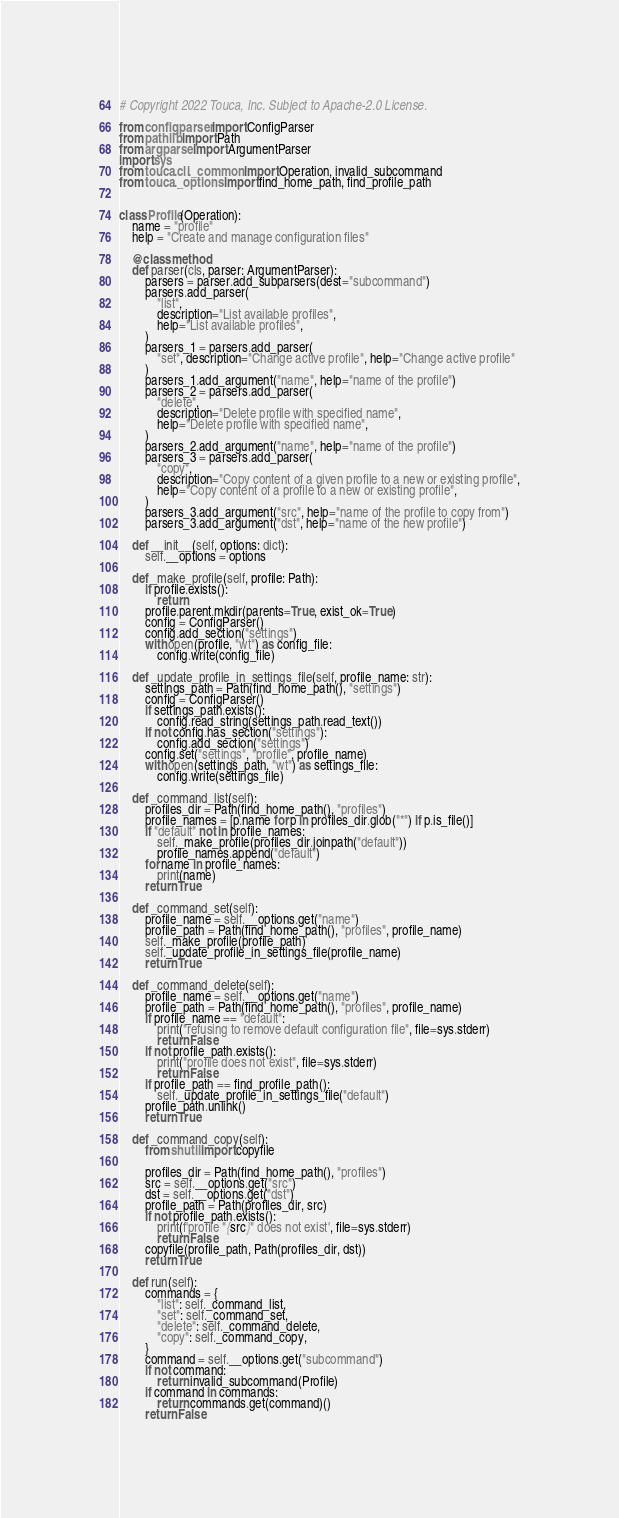Convert code to text. <code><loc_0><loc_0><loc_500><loc_500><_Python_># Copyright 2022 Touca, Inc. Subject to Apache-2.0 License.

from configparser import ConfigParser
from pathlib import Path
from argparse import ArgumentParser
import sys
from touca.cli._common import Operation, invalid_subcommand
from touca._options import find_home_path, find_profile_path


class Profile(Operation):
    name = "profile"
    help = "Create and manage configuration files"

    @classmethod
    def parser(cls, parser: ArgumentParser):
        parsers = parser.add_subparsers(dest="subcommand")
        parsers.add_parser(
            "list",
            description="List available profiles",
            help="List available profiles",
        )
        parsers_1 = parsers.add_parser(
            "set", description="Change active profile", help="Change active profile"
        )
        parsers_1.add_argument("name", help="name of the profile")
        parsers_2 = parsers.add_parser(
            "delete",
            description="Delete profile with specified name",
            help="Delete profile with specified name",
        )
        parsers_2.add_argument("name", help="name of the profile")
        parsers_3 = parsers.add_parser(
            "copy",
            description="Copy content of a given profile to a new or existing profile",
            help="Copy content of a profile to a new or existing profile",
        )
        parsers_3.add_argument("src", help="name of the profile to copy from")
        parsers_3.add_argument("dst", help="name of the new profile")

    def __init__(self, options: dict):
        self.__options = options

    def _make_profile(self, profile: Path):
        if profile.exists():
            return
        profile.parent.mkdir(parents=True, exist_ok=True)
        config = ConfigParser()
        config.add_section("settings")
        with open(profile, "wt") as config_file:
            config.write(config_file)

    def _update_profile_in_settings_file(self, profile_name: str):
        settings_path = Path(find_home_path(), "settings")
        config = ConfigParser()
        if settings_path.exists():
            config.read_string(settings_path.read_text())
        if not config.has_section("settings"):
            config.add_section("settings")
        config.set("settings", "profile", profile_name)
        with open(settings_path, "wt") as settings_file:
            config.write(settings_file)

    def _command_list(self):
        profiles_dir = Path(find_home_path(), "profiles")
        profile_names = [p.name for p in profiles_dir.glob("*") if p.is_file()]
        if "default" not in profile_names:
            self._make_profile(profiles_dir.joinpath("default"))
            profile_names.append("default")
        for name in profile_names:
            print(name)
        return True

    def _command_set(self):
        profile_name = self.__options.get("name")
        profile_path = Path(find_home_path(), "profiles", profile_name)
        self._make_profile(profile_path)
        self._update_profile_in_settings_file(profile_name)
        return True

    def _command_delete(self):
        profile_name = self.__options.get("name")
        profile_path = Path(find_home_path(), "profiles", profile_name)
        if profile_name == "default":
            print("refusing to remove default configuration file", file=sys.stderr)
            return False
        if not profile_path.exists():
            print("profile does not exist", file=sys.stderr)
            return False
        if profile_path == find_profile_path():
            self._update_profile_in_settings_file("default")
        profile_path.unlink()
        return True

    def _command_copy(self):
        from shutil import copyfile

        profiles_dir = Path(find_home_path(), "profiles")
        src = self.__options.get("src")
        dst = self.__options.get("dst")
        profile_path = Path(profiles_dir, src)
        if not profile_path.exists():
            print(f'profile "{src}" does not exist', file=sys.stderr)
            return False
        copyfile(profile_path, Path(profiles_dir, dst))
        return True

    def run(self):
        commands = {
            "list": self._command_list,
            "set": self._command_set,
            "delete": self._command_delete,
            "copy": self._command_copy,
        }
        command = self.__options.get("subcommand")
        if not command:
            return invalid_subcommand(Profile)
        if command in commands:
            return commands.get(command)()
        return False
</code> 